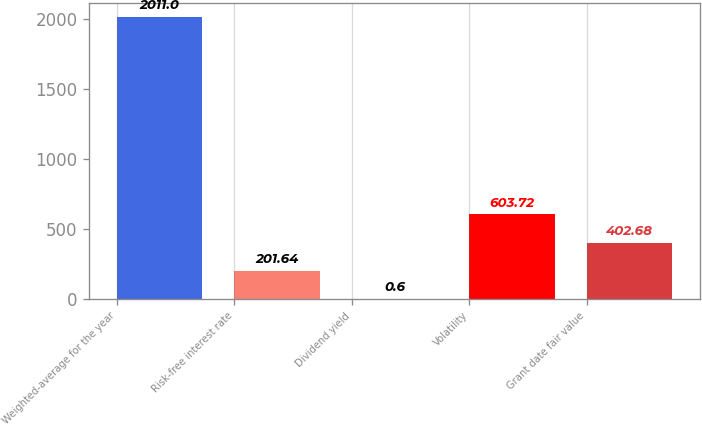Convert chart. <chart><loc_0><loc_0><loc_500><loc_500><bar_chart><fcel>Weighted-average for the year<fcel>Risk-free interest rate<fcel>Dividend yield<fcel>Volatility<fcel>Grant date fair value<nl><fcel>2011<fcel>201.64<fcel>0.6<fcel>603.72<fcel>402.68<nl></chart> 